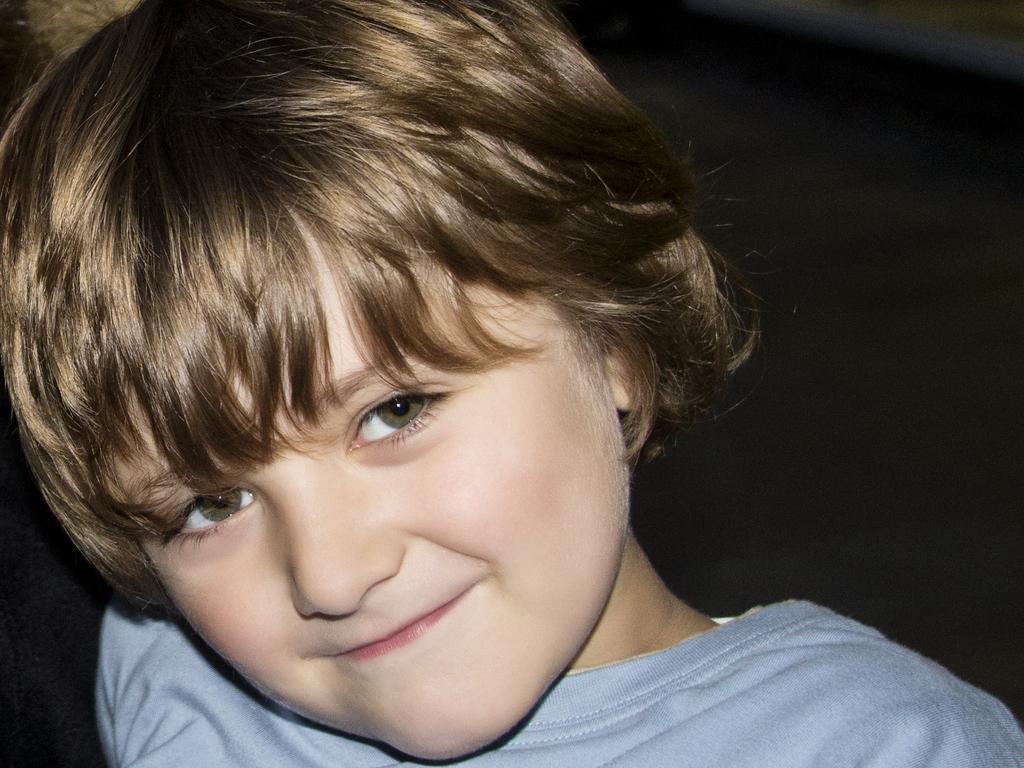In one or two sentences, can you explain what this image depicts? In this picture there is a kid. The kid is wearing a blue t-shirt. The background is dark. 